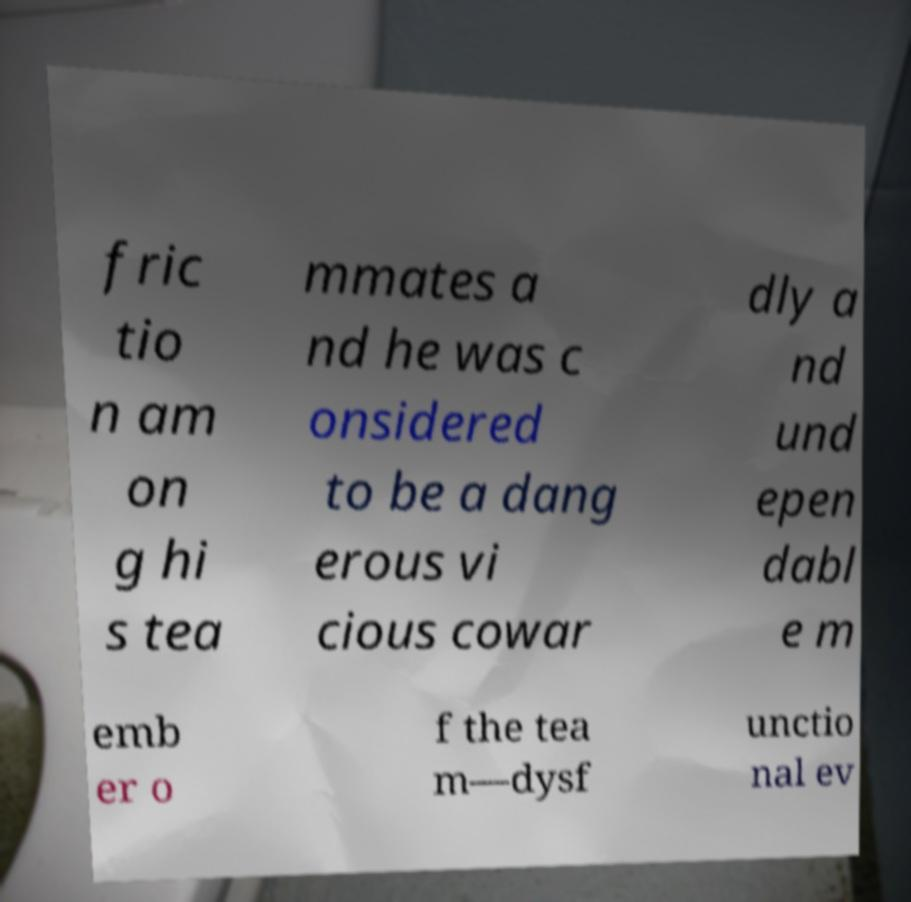Please read and relay the text visible in this image. What does it say? fric tio n am on g hi s tea mmates a nd he was c onsidered to be a dang erous vi cious cowar dly a nd und epen dabl e m emb er o f the tea m—dysf unctio nal ev 